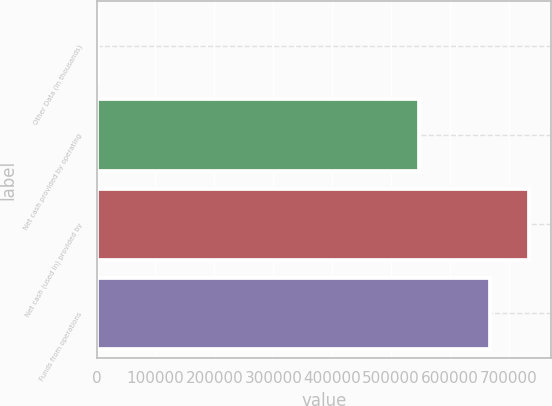Convert chart to OTSL. <chart><loc_0><loc_0><loc_500><loc_500><bar_chart><fcel>Other Data (in thousands)<fcel>Net cash provided by operating<fcel>Net cash (used in) provided by<fcel>Funds from operations<nl><fcel>2017<fcel>548373<fcel>735200<fcel>667294<nl></chart> 